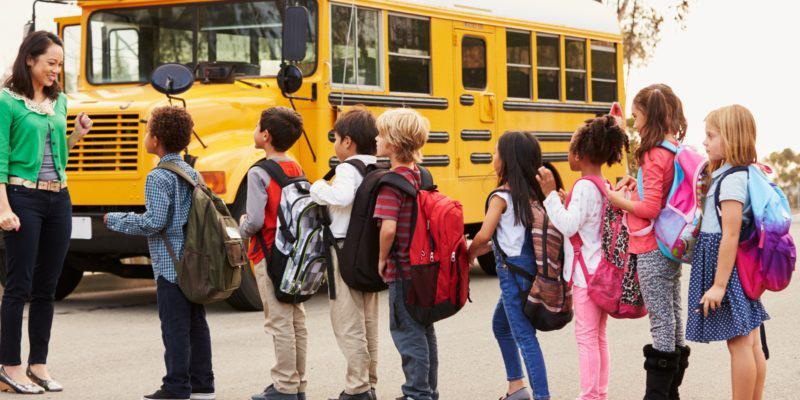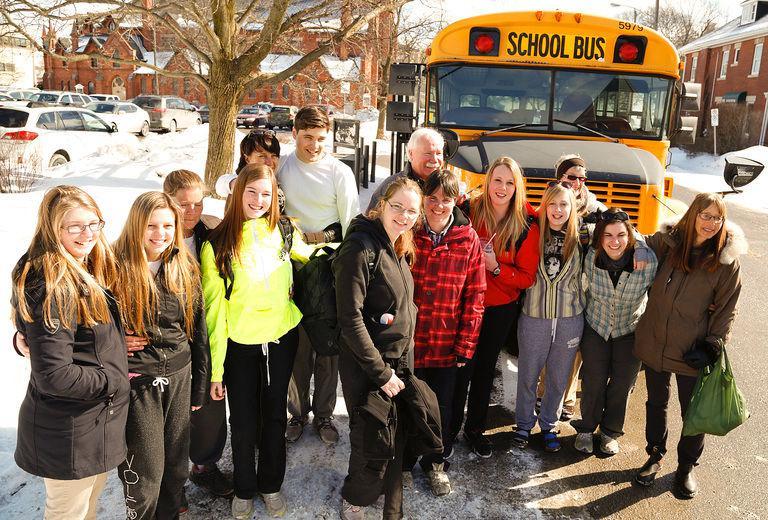The first image is the image on the left, the second image is the image on the right. Examine the images to the left and right. Is the description "In the left image there is a group of kids standing in front of a school bus, and the front end of the bus is visible." accurate? Answer yes or no. Yes. The first image is the image on the left, the second image is the image on the right. For the images shown, is this caption "Each image shows children facing the camera and standing side-by-side in at least one horizontal line in front of the entry-door side of the bus." true? Answer yes or no. No. 